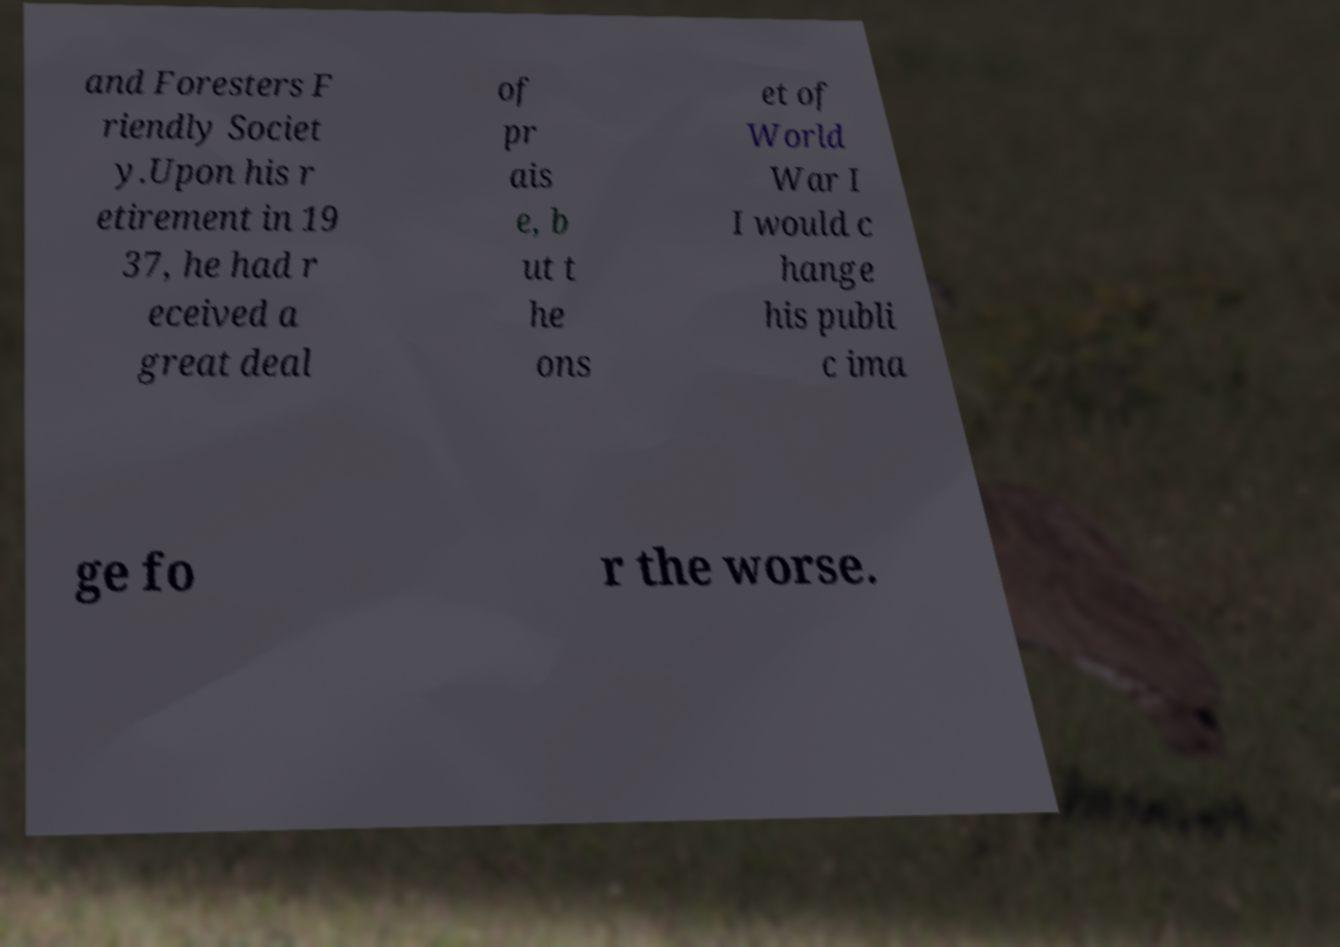Can you read and provide the text displayed in the image?This photo seems to have some interesting text. Can you extract and type it out for me? and Foresters F riendly Societ y.Upon his r etirement in 19 37, he had r eceived a great deal of pr ais e, b ut t he ons et of World War I I would c hange his publi c ima ge fo r the worse. 